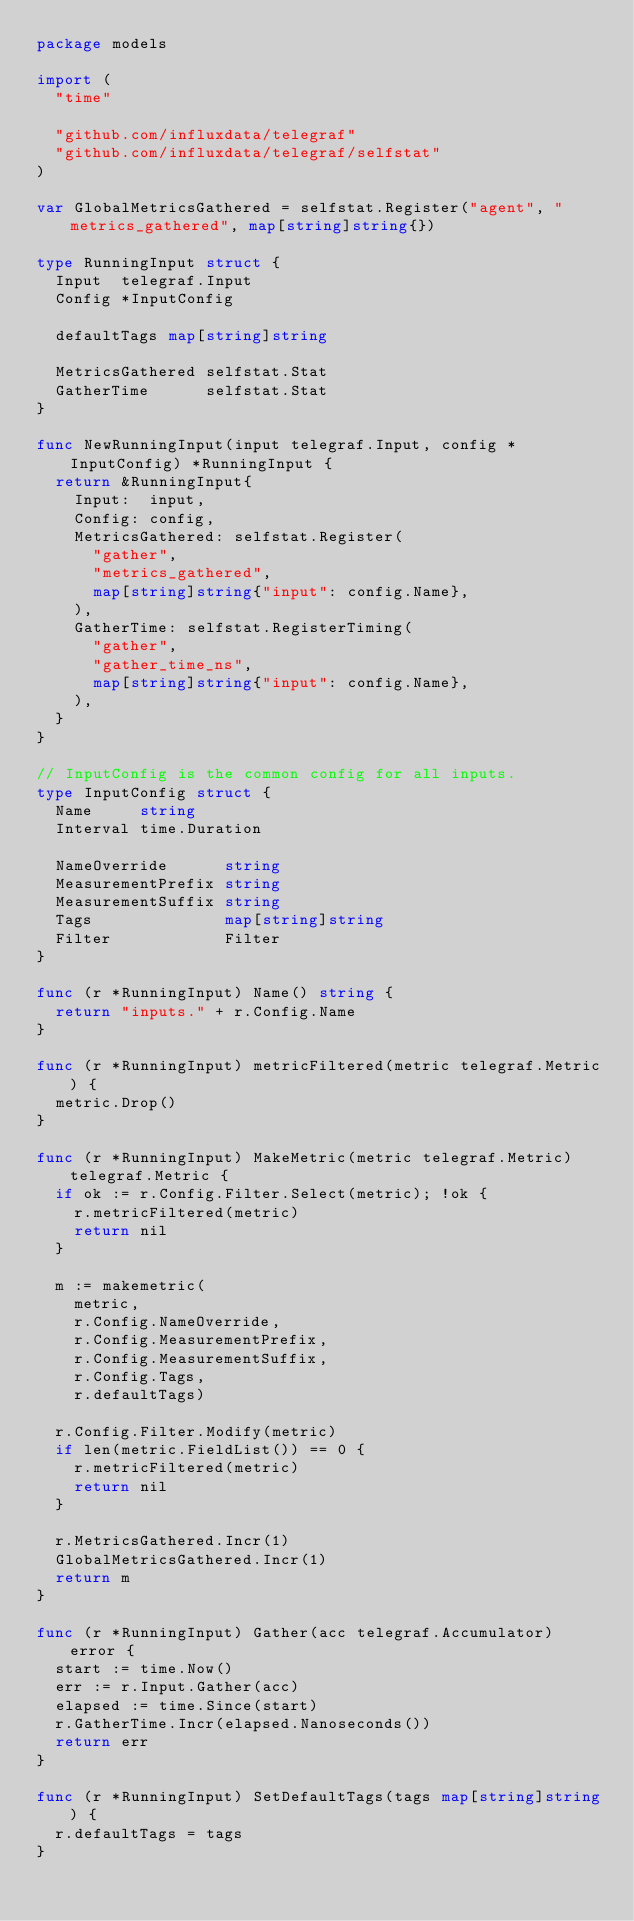<code> <loc_0><loc_0><loc_500><loc_500><_Go_>package models

import (
	"time"

	"github.com/influxdata/telegraf"
	"github.com/influxdata/telegraf/selfstat"
)

var GlobalMetricsGathered = selfstat.Register("agent", "metrics_gathered", map[string]string{})

type RunningInput struct {
	Input  telegraf.Input
	Config *InputConfig

	defaultTags map[string]string

	MetricsGathered selfstat.Stat
	GatherTime      selfstat.Stat
}

func NewRunningInput(input telegraf.Input, config *InputConfig) *RunningInput {
	return &RunningInput{
		Input:  input,
		Config: config,
		MetricsGathered: selfstat.Register(
			"gather",
			"metrics_gathered",
			map[string]string{"input": config.Name},
		),
		GatherTime: selfstat.RegisterTiming(
			"gather",
			"gather_time_ns",
			map[string]string{"input": config.Name},
		),
	}
}

// InputConfig is the common config for all inputs.
type InputConfig struct {
	Name     string
	Interval time.Duration

	NameOverride      string
	MeasurementPrefix string
	MeasurementSuffix string
	Tags              map[string]string
	Filter            Filter
}

func (r *RunningInput) Name() string {
	return "inputs." + r.Config.Name
}

func (r *RunningInput) metricFiltered(metric telegraf.Metric) {
	metric.Drop()
}

func (r *RunningInput) MakeMetric(metric telegraf.Metric) telegraf.Metric {
	if ok := r.Config.Filter.Select(metric); !ok {
		r.metricFiltered(metric)
		return nil
	}

	m := makemetric(
		metric,
		r.Config.NameOverride,
		r.Config.MeasurementPrefix,
		r.Config.MeasurementSuffix,
		r.Config.Tags,
		r.defaultTags)

	r.Config.Filter.Modify(metric)
	if len(metric.FieldList()) == 0 {
		r.metricFiltered(metric)
		return nil
	}

	r.MetricsGathered.Incr(1)
	GlobalMetricsGathered.Incr(1)
	return m
}

func (r *RunningInput) Gather(acc telegraf.Accumulator) error {
	start := time.Now()
	err := r.Input.Gather(acc)
	elapsed := time.Since(start)
	r.GatherTime.Incr(elapsed.Nanoseconds())
	return err
}

func (r *RunningInput) SetDefaultTags(tags map[string]string) {
	r.defaultTags = tags
}
</code> 